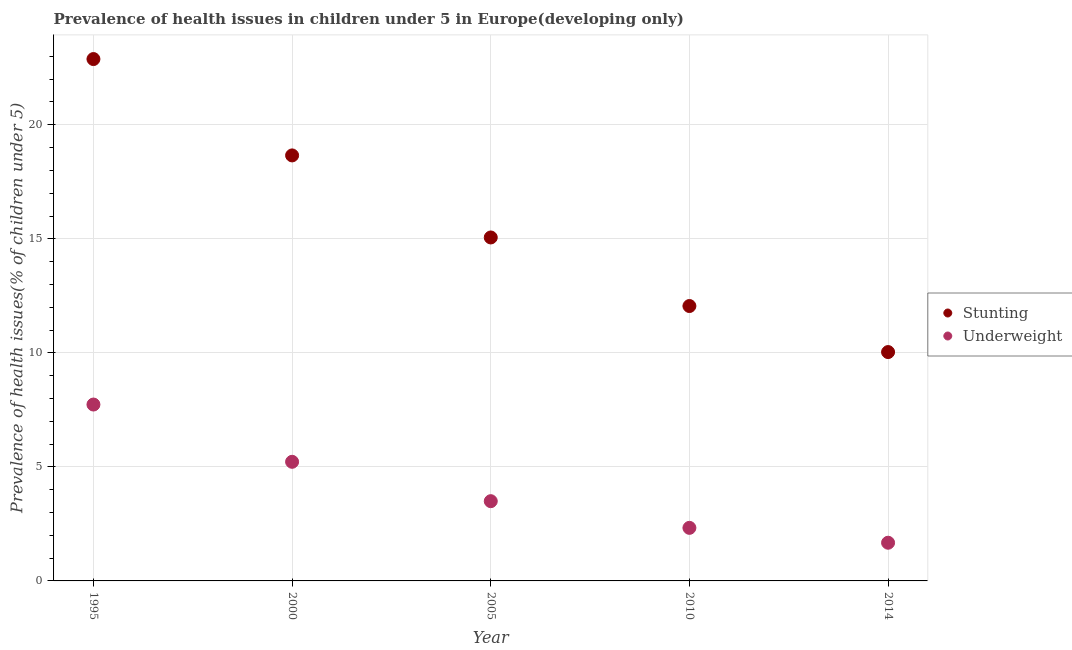How many different coloured dotlines are there?
Ensure brevity in your answer.  2. What is the percentage of underweight children in 2005?
Ensure brevity in your answer.  3.5. Across all years, what is the maximum percentage of stunted children?
Keep it short and to the point. 22.88. Across all years, what is the minimum percentage of stunted children?
Your answer should be compact. 10.03. In which year was the percentage of underweight children maximum?
Your answer should be compact. 1995. In which year was the percentage of underweight children minimum?
Provide a succinct answer. 2014. What is the total percentage of stunted children in the graph?
Provide a succinct answer. 78.68. What is the difference between the percentage of stunted children in 2000 and that in 2010?
Offer a terse response. 6.6. What is the difference between the percentage of underweight children in 2010 and the percentage of stunted children in 2014?
Offer a terse response. -7.71. What is the average percentage of underweight children per year?
Provide a succinct answer. 4.09. In the year 1995, what is the difference between the percentage of underweight children and percentage of stunted children?
Make the answer very short. -15.15. What is the ratio of the percentage of stunted children in 2000 to that in 2010?
Your response must be concise. 1.55. Is the percentage of underweight children in 2005 less than that in 2010?
Make the answer very short. No. What is the difference between the highest and the second highest percentage of stunted children?
Your answer should be very brief. 4.22. What is the difference between the highest and the lowest percentage of underweight children?
Provide a short and direct response. 6.06. In how many years, is the percentage of stunted children greater than the average percentage of stunted children taken over all years?
Offer a very short reply. 2. How many years are there in the graph?
Your response must be concise. 5. Does the graph contain any zero values?
Offer a terse response. No. Does the graph contain grids?
Offer a very short reply. Yes. How are the legend labels stacked?
Your response must be concise. Vertical. What is the title of the graph?
Offer a very short reply. Prevalence of health issues in children under 5 in Europe(developing only). What is the label or title of the X-axis?
Keep it short and to the point. Year. What is the label or title of the Y-axis?
Your answer should be compact. Prevalence of health issues(% of children under 5). What is the Prevalence of health issues(% of children under 5) of Stunting in 1995?
Provide a succinct answer. 22.88. What is the Prevalence of health issues(% of children under 5) of Underweight in 1995?
Your response must be concise. 7.73. What is the Prevalence of health issues(% of children under 5) in Stunting in 2000?
Keep it short and to the point. 18.66. What is the Prevalence of health issues(% of children under 5) of Underweight in 2000?
Provide a succinct answer. 5.22. What is the Prevalence of health issues(% of children under 5) of Stunting in 2005?
Provide a short and direct response. 15.06. What is the Prevalence of health issues(% of children under 5) in Underweight in 2005?
Offer a very short reply. 3.5. What is the Prevalence of health issues(% of children under 5) of Stunting in 2010?
Your answer should be compact. 12.05. What is the Prevalence of health issues(% of children under 5) of Underweight in 2010?
Ensure brevity in your answer.  2.33. What is the Prevalence of health issues(% of children under 5) of Stunting in 2014?
Keep it short and to the point. 10.03. What is the Prevalence of health issues(% of children under 5) of Underweight in 2014?
Offer a very short reply. 1.67. Across all years, what is the maximum Prevalence of health issues(% of children under 5) of Stunting?
Keep it short and to the point. 22.88. Across all years, what is the maximum Prevalence of health issues(% of children under 5) of Underweight?
Keep it short and to the point. 7.73. Across all years, what is the minimum Prevalence of health issues(% of children under 5) of Stunting?
Your answer should be compact. 10.03. Across all years, what is the minimum Prevalence of health issues(% of children under 5) of Underweight?
Offer a very short reply. 1.67. What is the total Prevalence of health issues(% of children under 5) of Stunting in the graph?
Provide a succinct answer. 78.68. What is the total Prevalence of health issues(% of children under 5) in Underweight in the graph?
Give a very brief answer. 20.45. What is the difference between the Prevalence of health issues(% of children under 5) in Stunting in 1995 and that in 2000?
Provide a short and direct response. 4.22. What is the difference between the Prevalence of health issues(% of children under 5) in Underweight in 1995 and that in 2000?
Provide a succinct answer. 2.51. What is the difference between the Prevalence of health issues(% of children under 5) in Stunting in 1995 and that in 2005?
Your answer should be very brief. 7.82. What is the difference between the Prevalence of health issues(% of children under 5) of Underweight in 1995 and that in 2005?
Your answer should be compact. 4.24. What is the difference between the Prevalence of health issues(% of children under 5) in Stunting in 1995 and that in 2010?
Offer a very short reply. 10.83. What is the difference between the Prevalence of health issues(% of children under 5) of Underweight in 1995 and that in 2010?
Offer a terse response. 5.41. What is the difference between the Prevalence of health issues(% of children under 5) of Stunting in 1995 and that in 2014?
Your response must be concise. 12.85. What is the difference between the Prevalence of health issues(% of children under 5) in Underweight in 1995 and that in 2014?
Your response must be concise. 6.06. What is the difference between the Prevalence of health issues(% of children under 5) of Stunting in 2000 and that in 2005?
Your response must be concise. 3.6. What is the difference between the Prevalence of health issues(% of children under 5) in Underweight in 2000 and that in 2005?
Offer a terse response. 1.73. What is the difference between the Prevalence of health issues(% of children under 5) in Stunting in 2000 and that in 2010?
Your answer should be compact. 6.6. What is the difference between the Prevalence of health issues(% of children under 5) of Underweight in 2000 and that in 2010?
Give a very brief answer. 2.9. What is the difference between the Prevalence of health issues(% of children under 5) of Stunting in 2000 and that in 2014?
Keep it short and to the point. 8.62. What is the difference between the Prevalence of health issues(% of children under 5) of Underweight in 2000 and that in 2014?
Ensure brevity in your answer.  3.55. What is the difference between the Prevalence of health issues(% of children under 5) of Stunting in 2005 and that in 2010?
Offer a very short reply. 3.01. What is the difference between the Prevalence of health issues(% of children under 5) of Underweight in 2005 and that in 2010?
Ensure brevity in your answer.  1.17. What is the difference between the Prevalence of health issues(% of children under 5) in Stunting in 2005 and that in 2014?
Ensure brevity in your answer.  5.02. What is the difference between the Prevalence of health issues(% of children under 5) in Underweight in 2005 and that in 2014?
Your response must be concise. 1.82. What is the difference between the Prevalence of health issues(% of children under 5) of Stunting in 2010 and that in 2014?
Make the answer very short. 2.02. What is the difference between the Prevalence of health issues(% of children under 5) in Underweight in 2010 and that in 2014?
Provide a short and direct response. 0.65. What is the difference between the Prevalence of health issues(% of children under 5) of Stunting in 1995 and the Prevalence of health issues(% of children under 5) of Underweight in 2000?
Make the answer very short. 17.66. What is the difference between the Prevalence of health issues(% of children under 5) of Stunting in 1995 and the Prevalence of health issues(% of children under 5) of Underweight in 2005?
Your answer should be very brief. 19.39. What is the difference between the Prevalence of health issues(% of children under 5) in Stunting in 1995 and the Prevalence of health issues(% of children under 5) in Underweight in 2010?
Give a very brief answer. 20.55. What is the difference between the Prevalence of health issues(% of children under 5) in Stunting in 1995 and the Prevalence of health issues(% of children under 5) in Underweight in 2014?
Your answer should be very brief. 21.21. What is the difference between the Prevalence of health issues(% of children under 5) in Stunting in 2000 and the Prevalence of health issues(% of children under 5) in Underweight in 2005?
Offer a terse response. 15.16. What is the difference between the Prevalence of health issues(% of children under 5) in Stunting in 2000 and the Prevalence of health issues(% of children under 5) in Underweight in 2010?
Provide a short and direct response. 16.33. What is the difference between the Prevalence of health issues(% of children under 5) in Stunting in 2000 and the Prevalence of health issues(% of children under 5) in Underweight in 2014?
Your answer should be compact. 16.98. What is the difference between the Prevalence of health issues(% of children under 5) of Stunting in 2005 and the Prevalence of health issues(% of children under 5) of Underweight in 2010?
Your answer should be very brief. 12.73. What is the difference between the Prevalence of health issues(% of children under 5) of Stunting in 2005 and the Prevalence of health issues(% of children under 5) of Underweight in 2014?
Make the answer very short. 13.38. What is the difference between the Prevalence of health issues(% of children under 5) in Stunting in 2010 and the Prevalence of health issues(% of children under 5) in Underweight in 2014?
Your response must be concise. 10.38. What is the average Prevalence of health issues(% of children under 5) in Stunting per year?
Provide a succinct answer. 15.74. What is the average Prevalence of health issues(% of children under 5) in Underweight per year?
Offer a terse response. 4.09. In the year 1995, what is the difference between the Prevalence of health issues(% of children under 5) in Stunting and Prevalence of health issues(% of children under 5) in Underweight?
Your answer should be very brief. 15.15. In the year 2000, what is the difference between the Prevalence of health issues(% of children under 5) in Stunting and Prevalence of health issues(% of children under 5) in Underweight?
Your answer should be very brief. 13.43. In the year 2005, what is the difference between the Prevalence of health issues(% of children under 5) in Stunting and Prevalence of health issues(% of children under 5) in Underweight?
Provide a short and direct response. 11.56. In the year 2010, what is the difference between the Prevalence of health issues(% of children under 5) in Stunting and Prevalence of health issues(% of children under 5) in Underweight?
Keep it short and to the point. 9.73. In the year 2014, what is the difference between the Prevalence of health issues(% of children under 5) of Stunting and Prevalence of health issues(% of children under 5) of Underweight?
Make the answer very short. 8.36. What is the ratio of the Prevalence of health issues(% of children under 5) of Stunting in 1995 to that in 2000?
Give a very brief answer. 1.23. What is the ratio of the Prevalence of health issues(% of children under 5) of Underweight in 1995 to that in 2000?
Offer a terse response. 1.48. What is the ratio of the Prevalence of health issues(% of children under 5) in Stunting in 1995 to that in 2005?
Keep it short and to the point. 1.52. What is the ratio of the Prevalence of health issues(% of children under 5) in Underweight in 1995 to that in 2005?
Your answer should be very brief. 2.21. What is the ratio of the Prevalence of health issues(% of children under 5) in Stunting in 1995 to that in 2010?
Provide a succinct answer. 1.9. What is the ratio of the Prevalence of health issues(% of children under 5) in Underweight in 1995 to that in 2010?
Your response must be concise. 3.32. What is the ratio of the Prevalence of health issues(% of children under 5) of Stunting in 1995 to that in 2014?
Offer a very short reply. 2.28. What is the ratio of the Prevalence of health issues(% of children under 5) of Underweight in 1995 to that in 2014?
Your response must be concise. 4.62. What is the ratio of the Prevalence of health issues(% of children under 5) in Stunting in 2000 to that in 2005?
Your response must be concise. 1.24. What is the ratio of the Prevalence of health issues(% of children under 5) in Underweight in 2000 to that in 2005?
Make the answer very short. 1.49. What is the ratio of the Prevalence of health issues(% of children under 5) of Stunting in 2000 to that in 2010?
Provide a succinct answer. 1.55. What is the ratio of the Prevalence of health issues(% of children under 5) of Underweight in 2000 to that in 2010?
Provide a short and direct response. 2.24. What is the ratio of the Prevalence of health issues(% of children under 5) in Stunting in 2000 to that in 2014?
Provide a short and direct response. 1.86. What is the ratio of the Prevalence of health issues(% of children under 5) of Underweight in 2000 to that in 2014?
Give a very brief answer. 3.12. What is the ratio of the Prevalence of health issues(% of children under 5) of Stunting in 2005 to that in 2010?
Keep it short and to the point. 1.25. What is the ratio of the Prevalence of health issues(% of children under 5) of Underweight in 2005 to that in 2010?
Ensure brevity in your answer.  1.5. What is the ratio of the Prevalence of health issues(% of children under 5) of Stunting in 2005 to that in 2014?
Your answer should be compact. 1.5. What is the ratio of the Prevalence of health issues(% of children under 5) in Underweight in 2005 to that in 2014?
Provide a short and direct response. 2.09. What is the ratio of the Prevalence of health issues(% of children under 5) in Stunting in 2010 to that in 2014?
Your answer should be compact. 1.2. What is the ratio of the Prevalence of health issues(% of children under 5) in Underweight in 2010 to that in 2014?
Provide a short and direct response. 1.39. What is the difference between the highest and the second highest Prevalence of health issues(% of children under 5) of Stunting?
Make the answer very short. 4.22. What is the difference between the highest and the second highest Prevalence of health issues(% of children under 5) of Underweight?
Keep it short and to the point. 2.51. What is the difference between the highest and the lowest Prevalence of health issues(% of children under 5) of Stunting?
Your answer should be compact. 12.85. What is the difference between the highest and the lowest Prevalence of health issues(% of children under 5) of Underweight?
Offer a terse response. 6.06. 